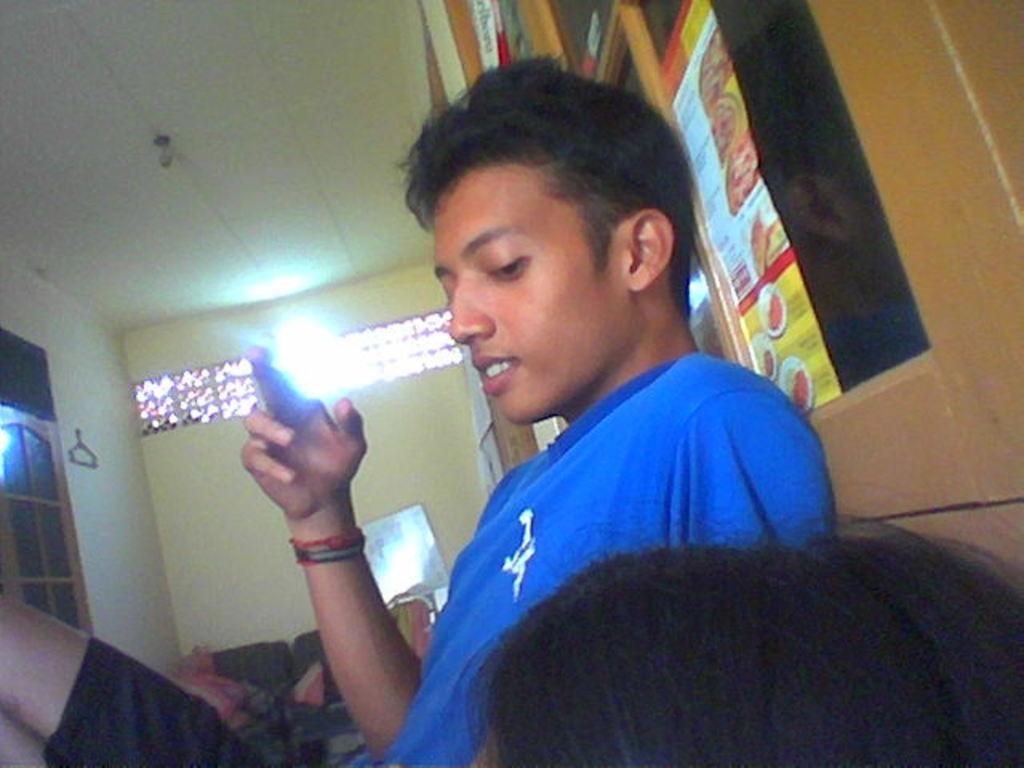Who is the main subject in the picture? There is a boy in the picture. What is the boy wearing? The boy is wearing a blue shirt. What is the boy holding in his hand? The boy is holding an object in his hand. What can be seen in the background of the picture? There is a wall in the background of the picture. What type of trucks can be seen in the picture? There are no trucks present in the picture; it features a boy wearing a blue shirt and holding an object. What advice does the boy's dad give him in the picture? There is no indication of the boy's dad or any advice-giving in the picture. 